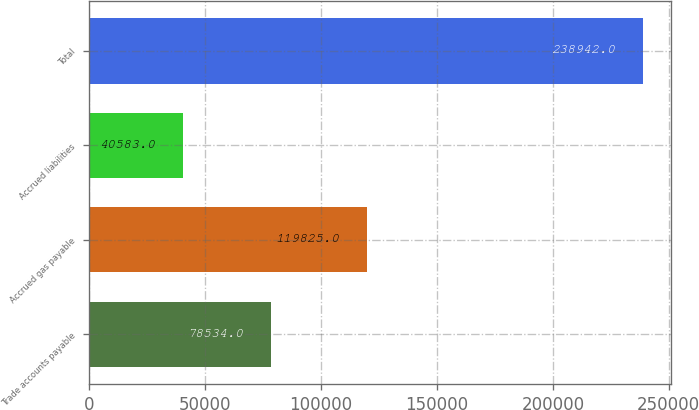Convert chart. <chart><loc_0><loc_0><loc_500><loc_500><bar_chart><fcel>Trade accounts payable<fcel>Accrued gas payable<fcel>Accrued liabilities<fcel>Total<nl><fcel>78534<fcel>119825<fcel>40583<fcel>238942<nl></chart> 